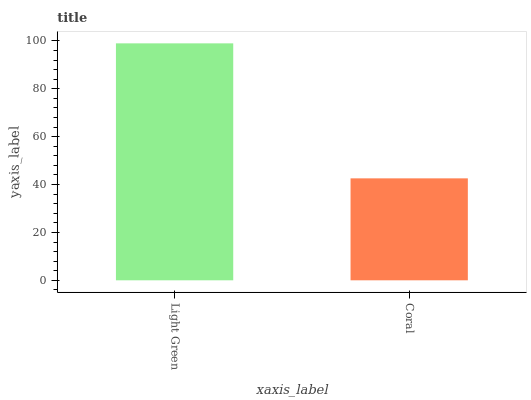Is Coral the minimum?
Answer yes or no. Yes. Is Light Green the maximum?
Answer yes or no. Yes. Is Coral the maximum?
Answer yes or no. No. Is Light Green greater than Coral?
Answer yes or no. Yes. Is Coral less than Light Green?
Answer yes or no. Yes. Is Coral greater than Light Green?
Answer yes or no. No. Is Light Green less than Coral?
Answer yes or no. No. Is Light Green the high median?
Answer yes or no. Yes. Is Coral the low median?
Answer yes or no. Yes. Is Coral the high median?
Answer yes or no. No. Is Light Green the low median?
Answer yes or no. No. 